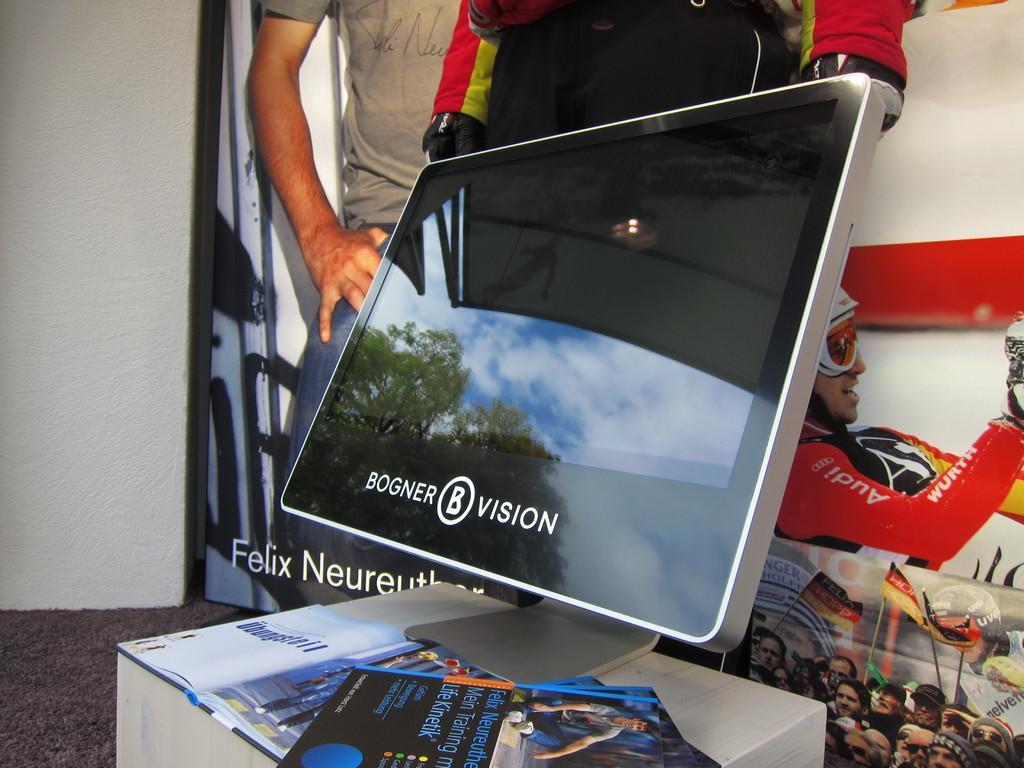Can you describe this image briefly? In this picture I can see the computer screen which is kept on the table, beside that I can see some books. in the back I can see the banner. In that banner I can see the person. 